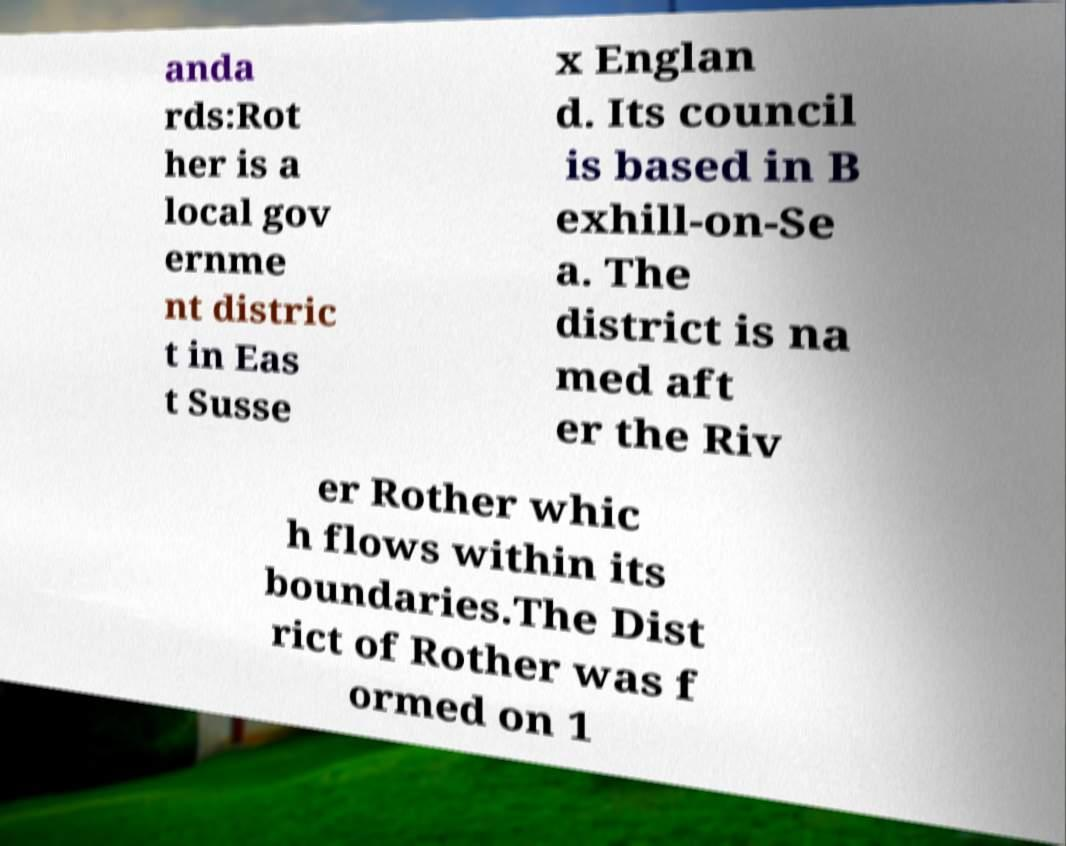Can you accurately transcribe the text from the provided image for me? anda rds:Rot her is a local gov ernme nt distric t in Eas t Susse x Englan d. Its council is based in B exhill-on-Se a. The district is na med aft er the Riv er Rother whic h flows within its boundaries.The Dist rict of Rother was f ormed on 1 